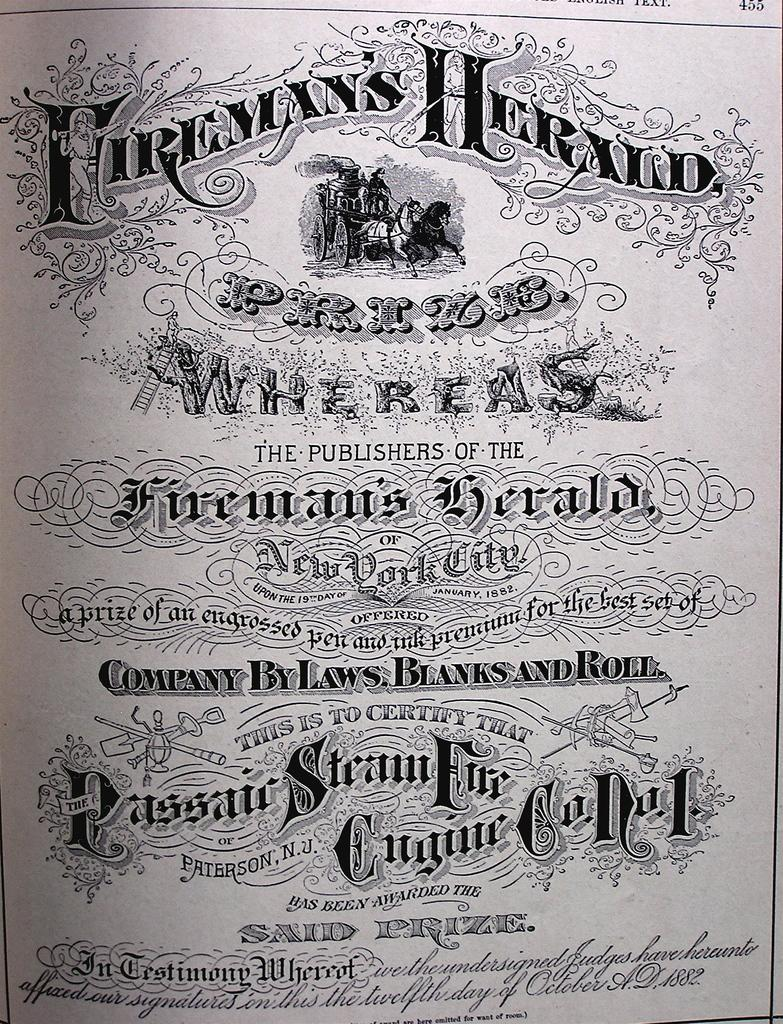<image>
Summarize the visual content of the image. A picture of a man on a horse is below the heading Fireman's Herald. 